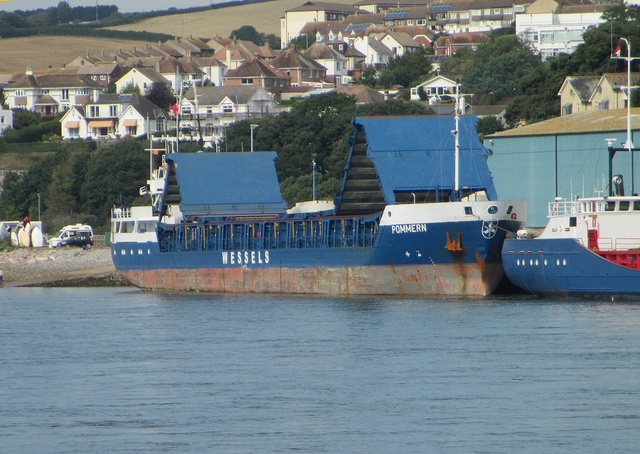Describe the objects in this image and their specific colors. I can see boat in gold, blue, darkblue, and gray tones, boat in gold, blue, lightgray, and black tones, truck in gold, ivory, gray, darkgray, and khaki tones, and car in gold, gray, black, and blue tones in this image. 